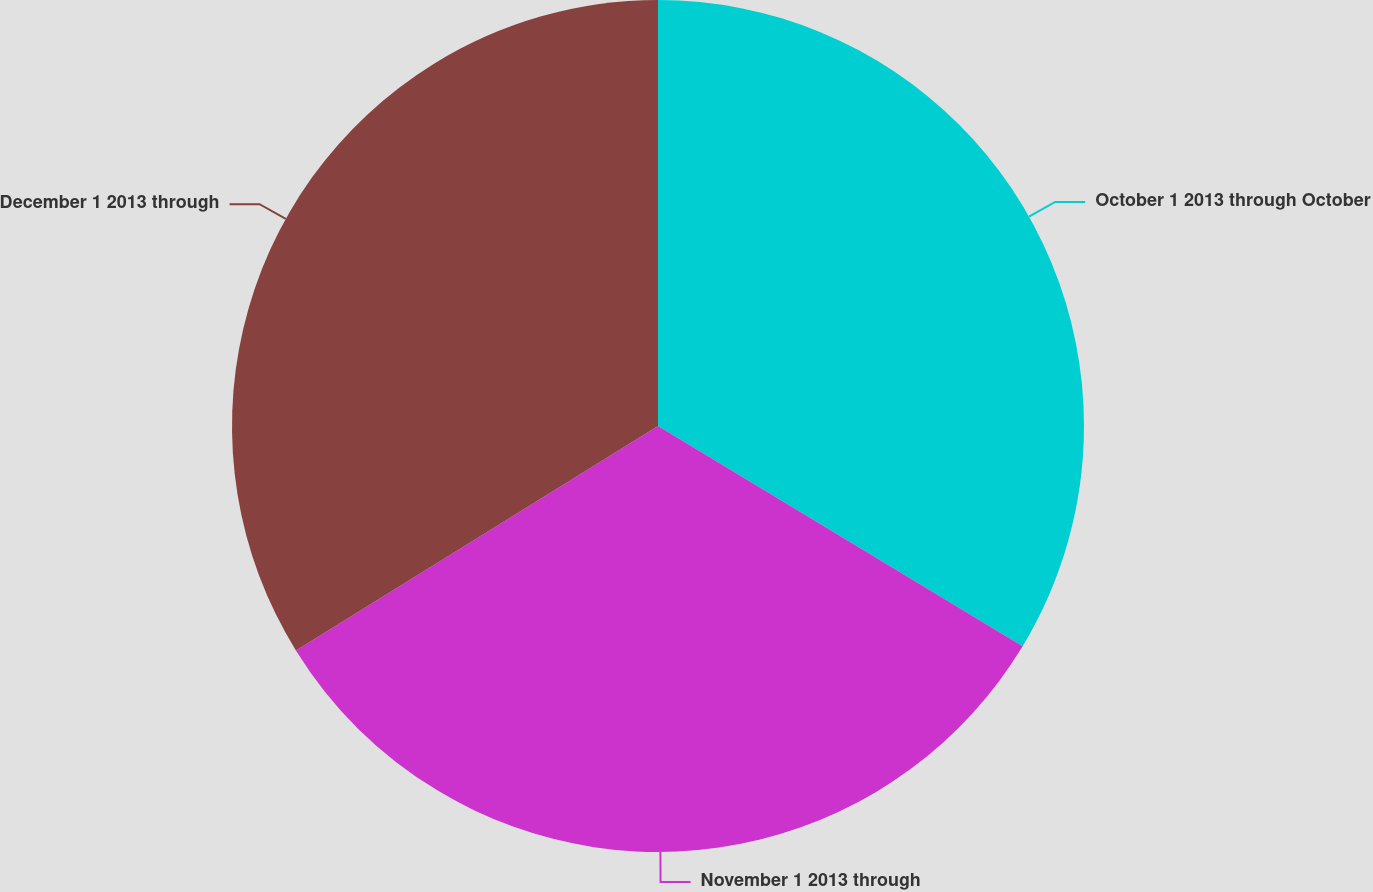<chart> <loc_0><loc_0><loc_500><loc_500><pie_chart><fcel>October 1 2013 through October<fcel>November 1 2013 through<fcel>December 1 2013 through<nl><fcel>33.65%<fcel>32.52%<fcel>33.83%<nl></chart> 